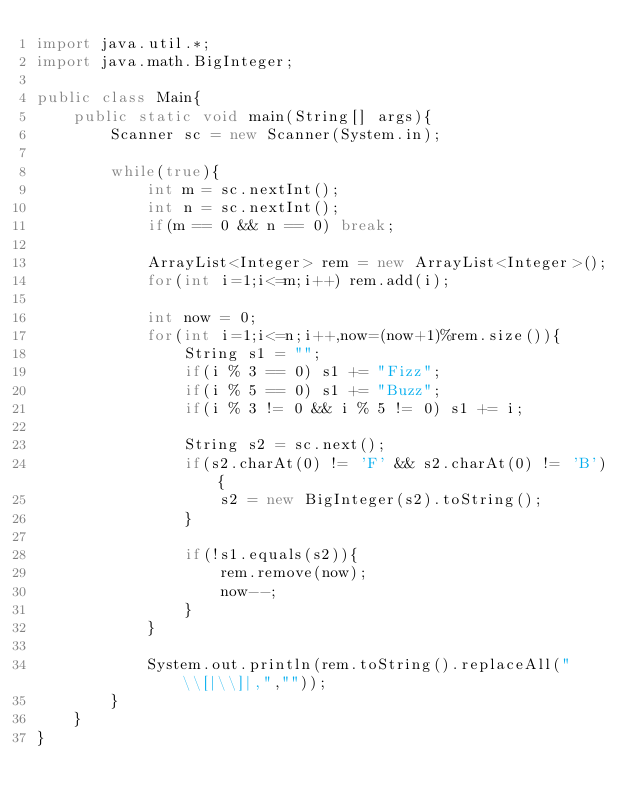<code> <loc_0><loc_0><loc_500><loc_500><_Java_>import java.util.*;
import java.math.BigInteger;

public class Main{
	public static void main(String[] args){
		Scanner sc = new Scanner(System.in);

		while(true){
			int m = sc.nextInt();
			int n = sc.nextInt();
			if(m == 0 && n == 0) break;

			ArrayList<Integer> rem = new ArrayList<Integer>();
			for(int i=1;i<=m;i++) rem.add(i);

			int now = 0;
			for(int i=1;i<=n;i++,now=(now+1)%rem.size()){
				String s1 = "";
				if(i % 3 == 0) s1 += "Fizz";
				if(i % 5 == 0) s1 += "Buzz";
				if(i % 3 != 0 && i % 5 != 0) s1 += i;

				String s2 = sc.next();
				if(s2.charAt(0) != 'F' && s2.charAt(0) != 'B'){
					s2 = new BigInteger(s2).toString();
				}

				if(!s1.equals(s2)){
					rem.remove(now);
					now--;
				}
			}

			System.out.println(rem.toString().replaceAll("\\[|\\]|,",""));
		}
	}
}</code> 